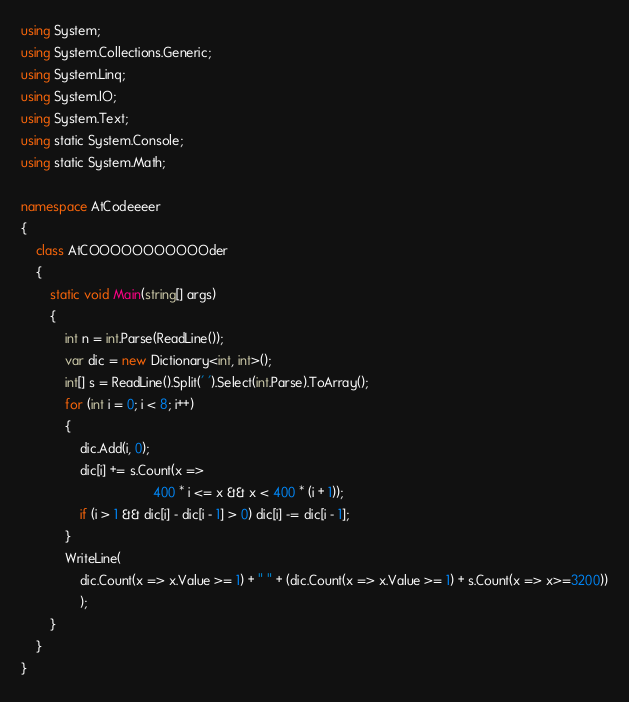Convert code to text. <code><loc_0><loc_0><loc_500><loc_500><_C#_>using System;
using System.Collections.Generic;
using System.Linq;
using System.IO;
using System.Text;
using static System.Console;
using static System.Math;

namespace AtCodeeeer
{
    class AtCOOOOOOOOOOOder
    {
        static void Main(string[] args)
        {
            int n = int.Parse(ReadLine());
            var dic = new Dictionary<int, int>();
            int[] s = ReadLine().Split(' ').Select(int.Parse).ToArray();
            for (int i = 0; i < 8; i++)
            {
                dic.Add(i, 0);
                dic[i] += s.Count(x =>
                                    400 * i <= x && x < 400 * (i + 1));
                if (i > 1 && dic[i] - dic[i - 1] > 0) dic[i] -= dic[i - 1];
            }
            WriteLine(
                dic.Count(x => x.Value >= 1) + " " + (dic.Count(x => x.Value >= 1) + s.Count(x => x>=3200))
                );
        }
    }
}</code> 